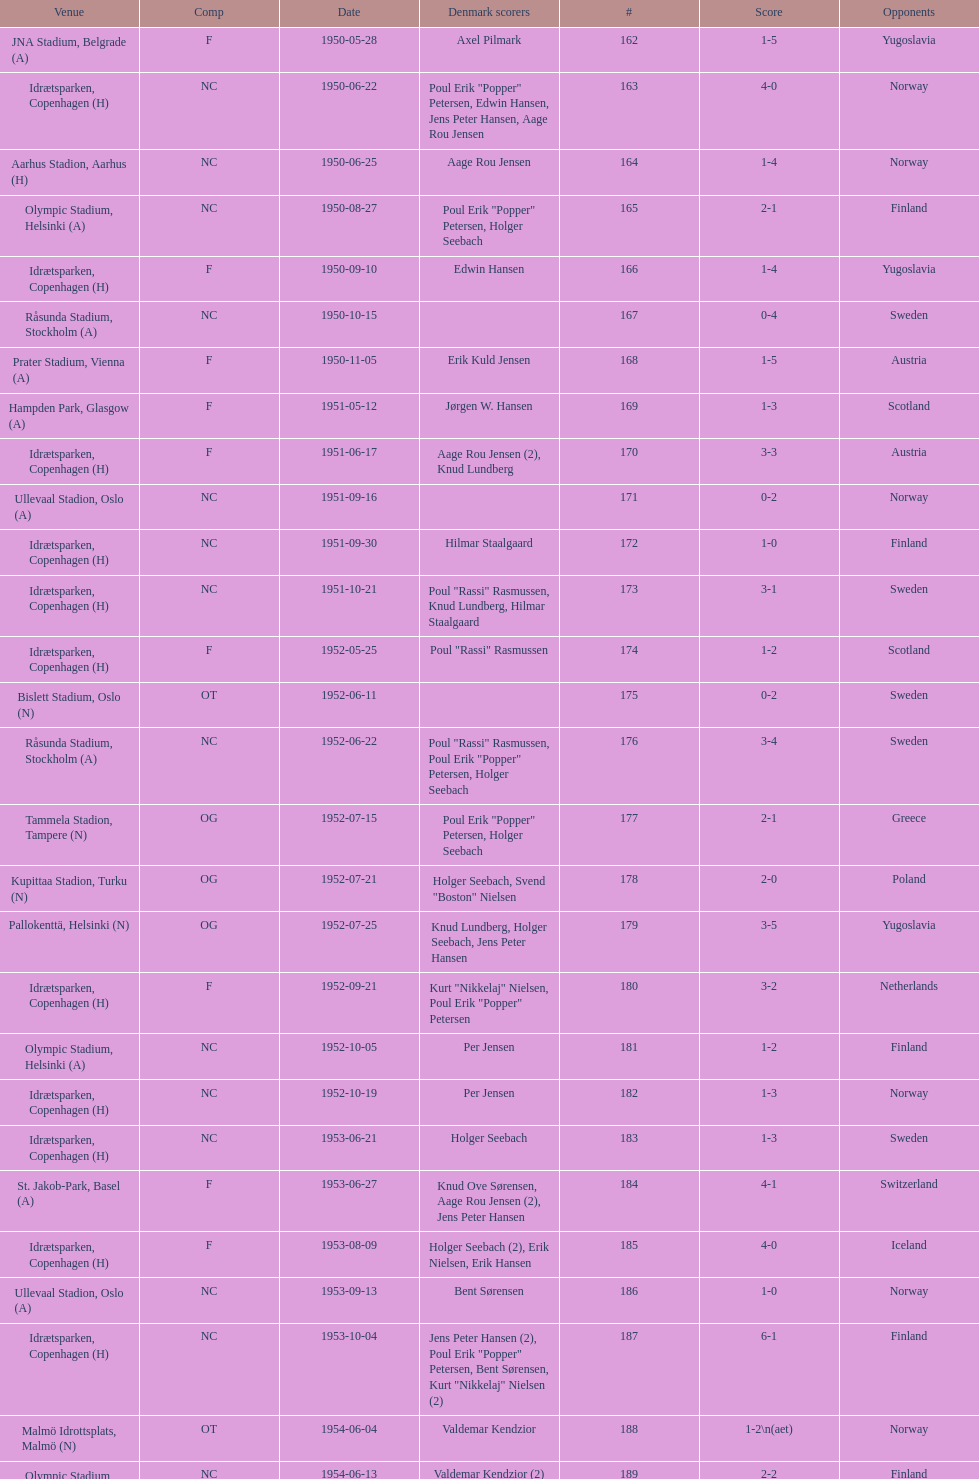What is the name of the venue listed before olympic stadium on 1950-08-27? Aarhus Stadion, Aarhus. 